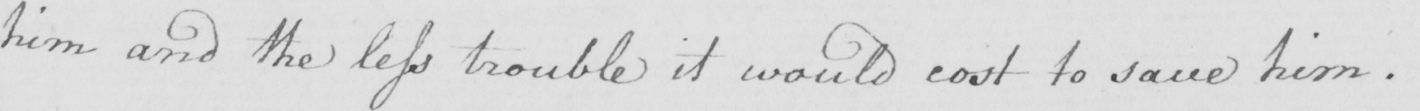What does this handwritten line say? him and the less trouble it would cost to save him . 